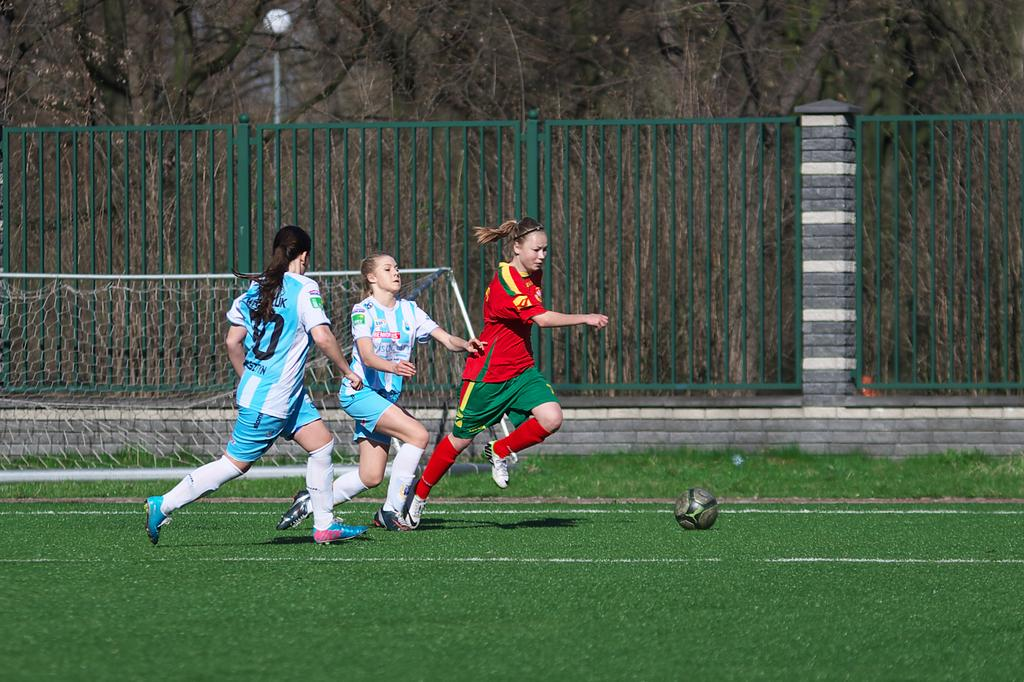<image>
Give a short and clear explanation of the subsequent image. Three girls on a field going towards a soccer ball with one girl wearing a uniform that has 10 on the back 